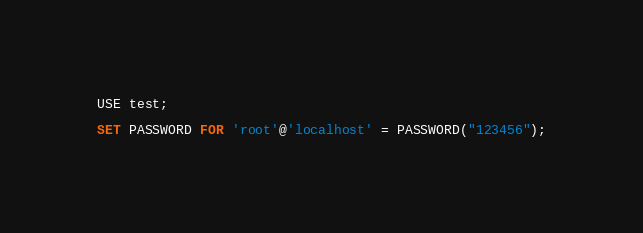Convert code to text. <code><loc_0><loc_0><loc_500><loc_500><_SQL_>USE test;

SET PASSWORD FOR 'root'@'localhost' = PASSWORD("123456");</code> 